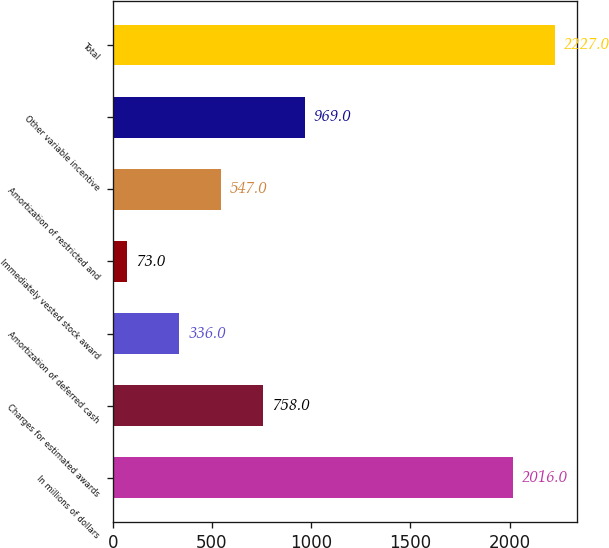Convert chart. <chart><loc_0><loc_0><loc_500><loc_500><bar_chart><fcel>In millions of dollars<fcel>Charges for estimated awards<fcel>Amortization of deferred cash<fcel>Immediately vested stock award<fcel>Amortization of restricted and<fcel>Other variable incentive<fcel>Total<nl><fcel>2016<fcel>758<fcel>336<fcel>73<fcel>547<fcel>969<fcel>2227<nl></chart> 